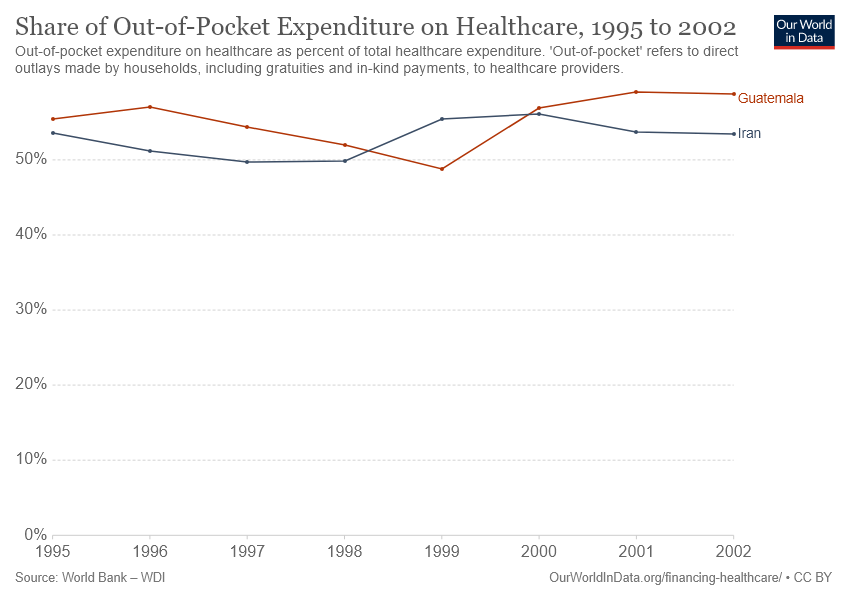Give some essential details in this illustration. In 2002, the color with the highest value was orange. 